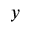Convert formula to latex. <formula><loc_0><loc_0><loc_500><loc_500>{ _ { y } }</formula> 